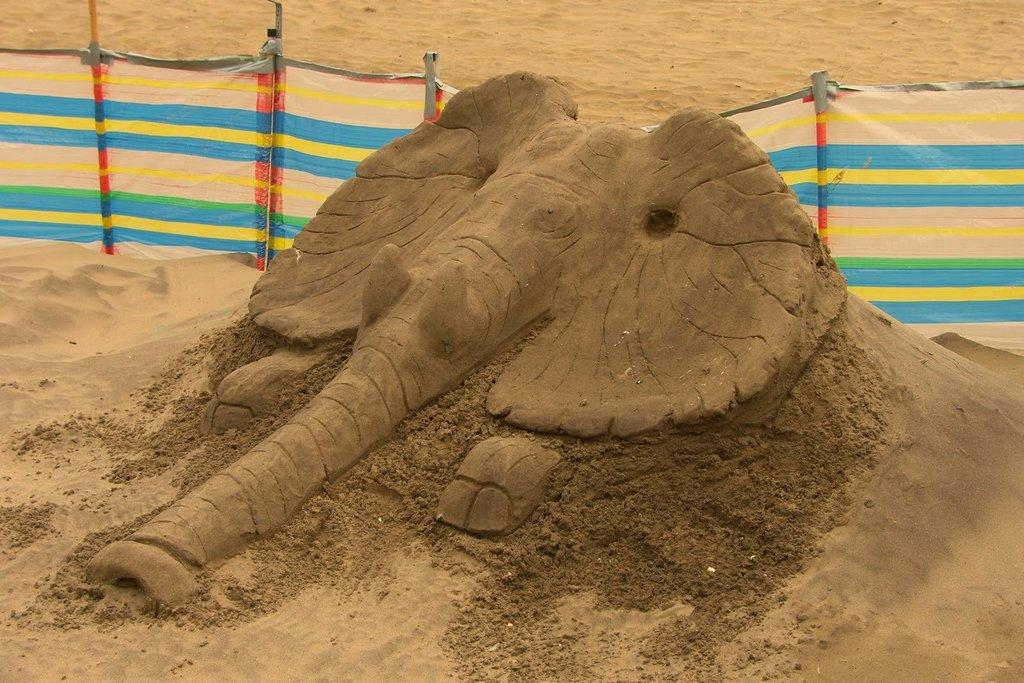What is the main subject of the sand carving in the image? The main subject of the sand carving in the image is an elephant. What material is the elephant made of in the image? The elephant is made of sand in the image. What colors are present on the sheet in the image? The sheet in the image has blue, yellow, and red colors. What type of objects are the small poles in the image? The small poles in the image are not clearly identifiable, but they could be used for various purposes. How many legs does the elephant have in the image? The image is a sand carving, and as such, it does not have legs like a real elephant. 